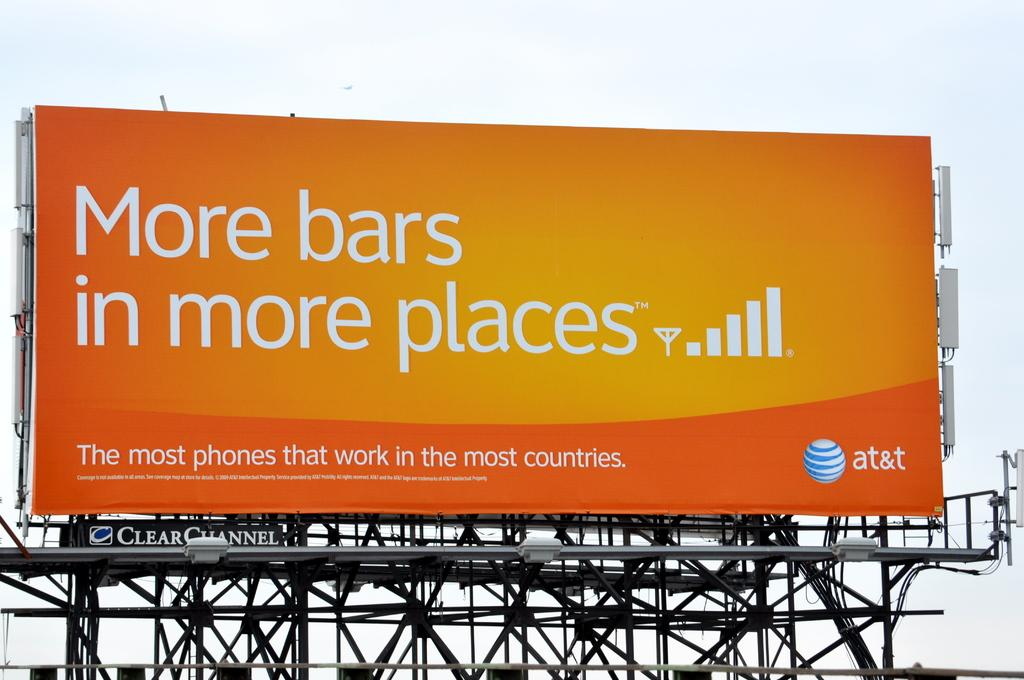Provide a one-sentence caption for the provided image. A billboard sign that says more bars in more places on it. 